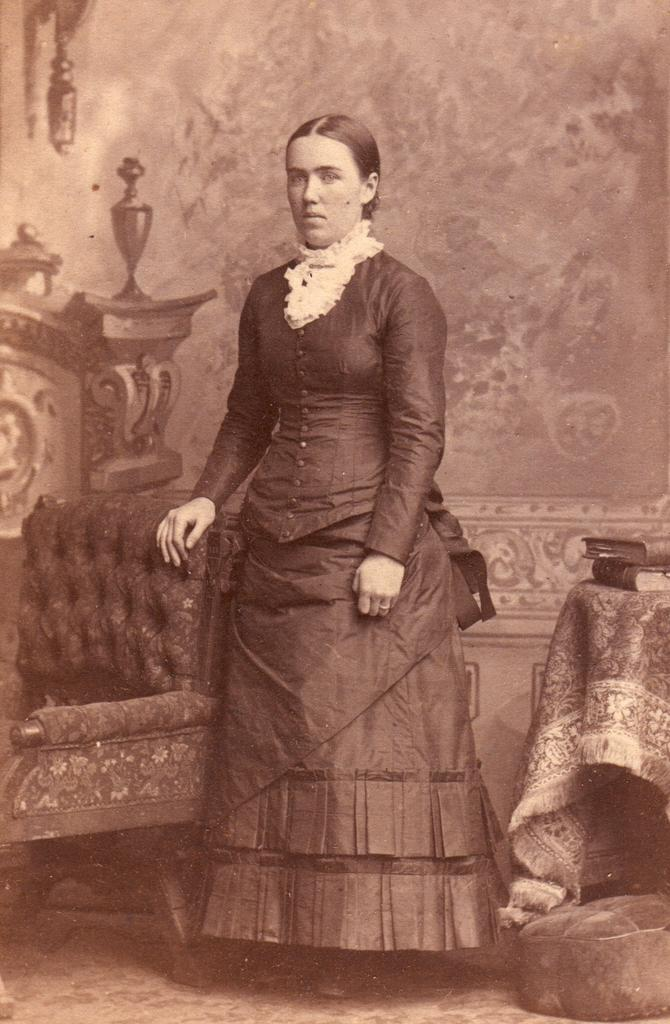What is the main subject of the image? There is a woman standing in the image. What object is visible in the image besides the woman? There is a chair in the image. Where are the books located in the image? The books are on the right side of the image. What can be seen in the background of the image? There is a wall in the background of the image. What type of furniture is present on the floor in the image? There appears to be a cushion on the floor in the image. What type of punishment is being administered to the woman in the image? There is no indication of punishment in the image; the woman is simply standing. What color are the woman's eyes in the image? The color of the woman's eyes is not mentioned in the provided facts, so it cannot be determined from the image. 